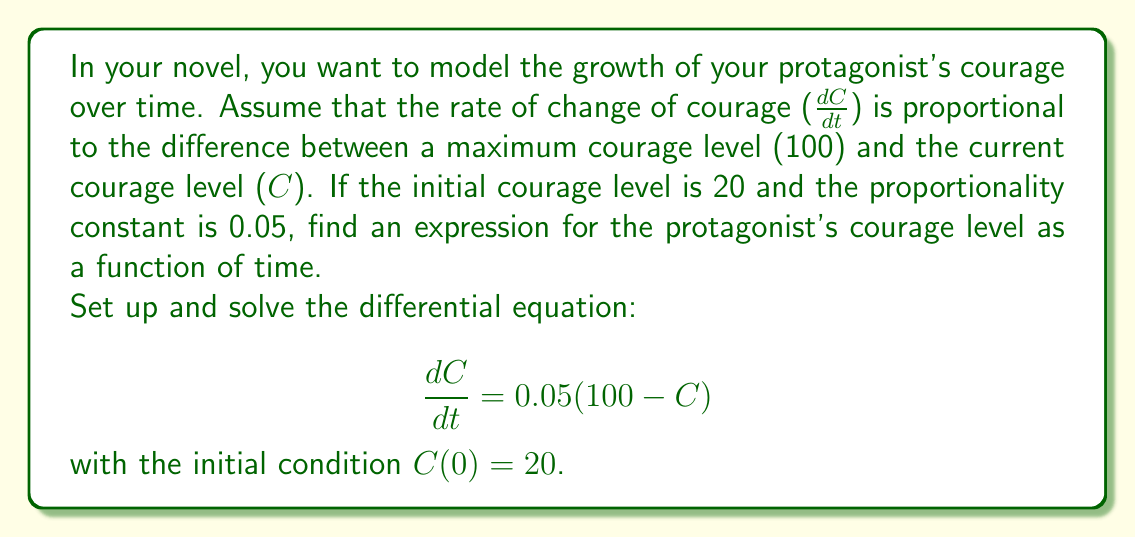Could you help me with this problem? Let's solve this first-order differential equation step by step:

1) The given differential equation is:
   $$\frac{dC}{dt} = 0.05(100 - C)$$

2) This is a separable equation. Let's rearrange it:
   $$\frac{dC}{100 - C} = 0.05dt$$

3) Integrate both sides:
   $$\int \frac{dC}{100 - C} = \int 0.05dt$$

4) The left side integrates to $-\ln|100 - C|$, and the right side to $0.05t + K$:
   $$-\ln|100 - C| = 0.05t + K$$

5) Solve for C:
   $$\ln|100 - C| = -0.05t - K$$
   $$100 - C = e^{-0.05t - K} = Ae^{-0.05t}$$, where $A = e^{-K}$
   $$C = 100 - Ae^{-0.05t}$$

6) Use the initial condition $C(0) = 20$ to find A:
   $$20 = 100 - A$$
   $$A = 80$$

7) Therefore, the final solution is:
   $$C(t) = 100 - 80e^{-0.05t}$$

This equation models how the protagonist's courage grows from 20 towards the maximum of 100 over time.
Answer: $C(t) = 100 - 80e^{-0.05t}$ 